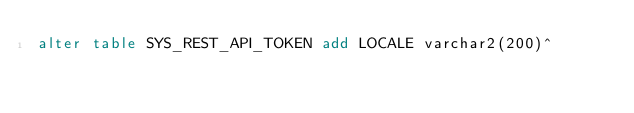<code> <loc_0><loc_0><loc_500><loc_500><_SQL_>alter table SYS_REST_API_TOKEN add LOCALE varchar2(200)^</code> 